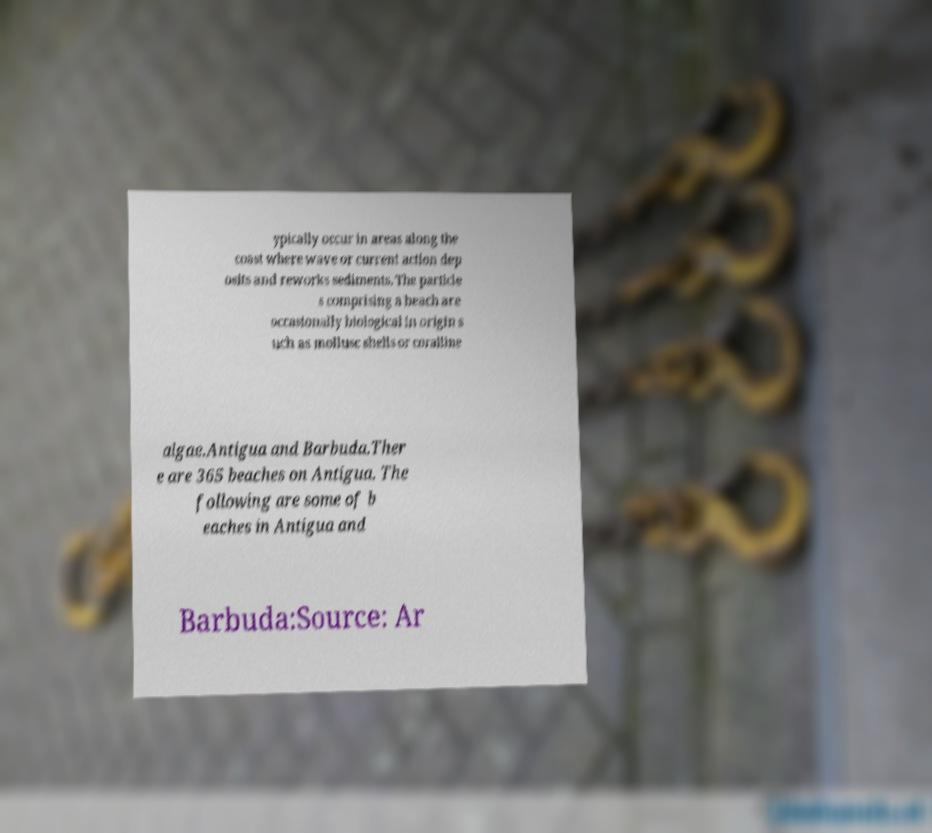I need the written content from this picture converted into text. Can you do that? ypically occur in areas along the coast where wave or current action dep osits and reworks sediments. The particle s comprising a beach are occasionally biological in origin s uch as mollusc shells or coralline algae.Antigua and Barbuda.Ther e are 365 beaches on Antigua. The following are some of b eaches in Antigua and Barbuda:Source: Ar 